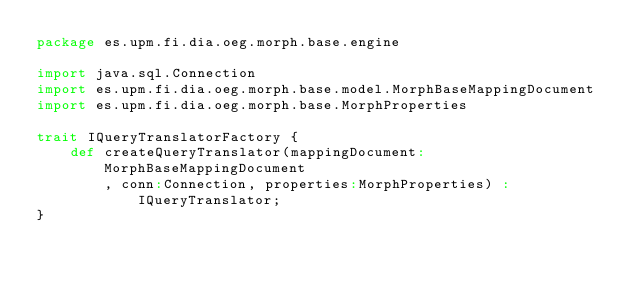Convert code to text. <code><loc_0><loc_0><loc_500><loc_500><_Scala_>package es.upm.fi.dia.oeg.morph.base.engine

import java.sql.Connection
import es.upm.fi.dia.oeg.morph.base.model.MorphBaseMappingDocument
import es.upm.fi.dia.oeg.morph.base.MorphProperties

trait IQueryTranslatorFactory {
	def createQueryTranslator(mappingDocument:MorphBaseMappingDocument
	    , conn:Connection, properties:MorphProperties) : IQueryTranslator;
}</code> 